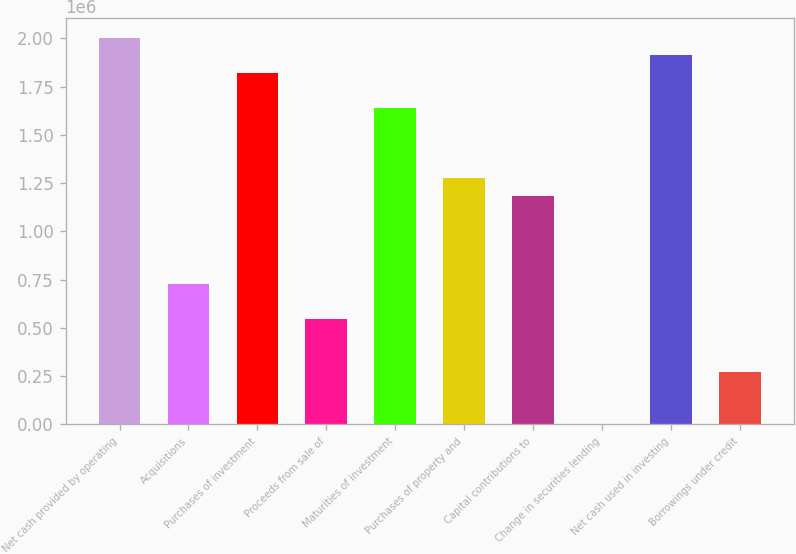Convert chart. <chart><loc_0><loc_0><loc_500><loc_500><bar_chart><fcel>Net cash provided by operating<fcel>Acquisitions<fcel>Purchases of investment<fcel>Proceeds from sale of<fcel>Maturities of investment<fcel>Purchases of property and<fcel>Capital contributions to<fcel>Change in securities lending<fcel>Net cash used in investing<fcel>Borrowings under credit<nl><fcel>2.0044e+06<fcel>728872<fcel>1.82218e+06<fcel>546654<fcel>1.63996e+06<fcel>1.27553e+06<fcel>1.18442e+06<fcel>0.6<fcel>1.91329e+06<fcel>273327<nl></chart> 